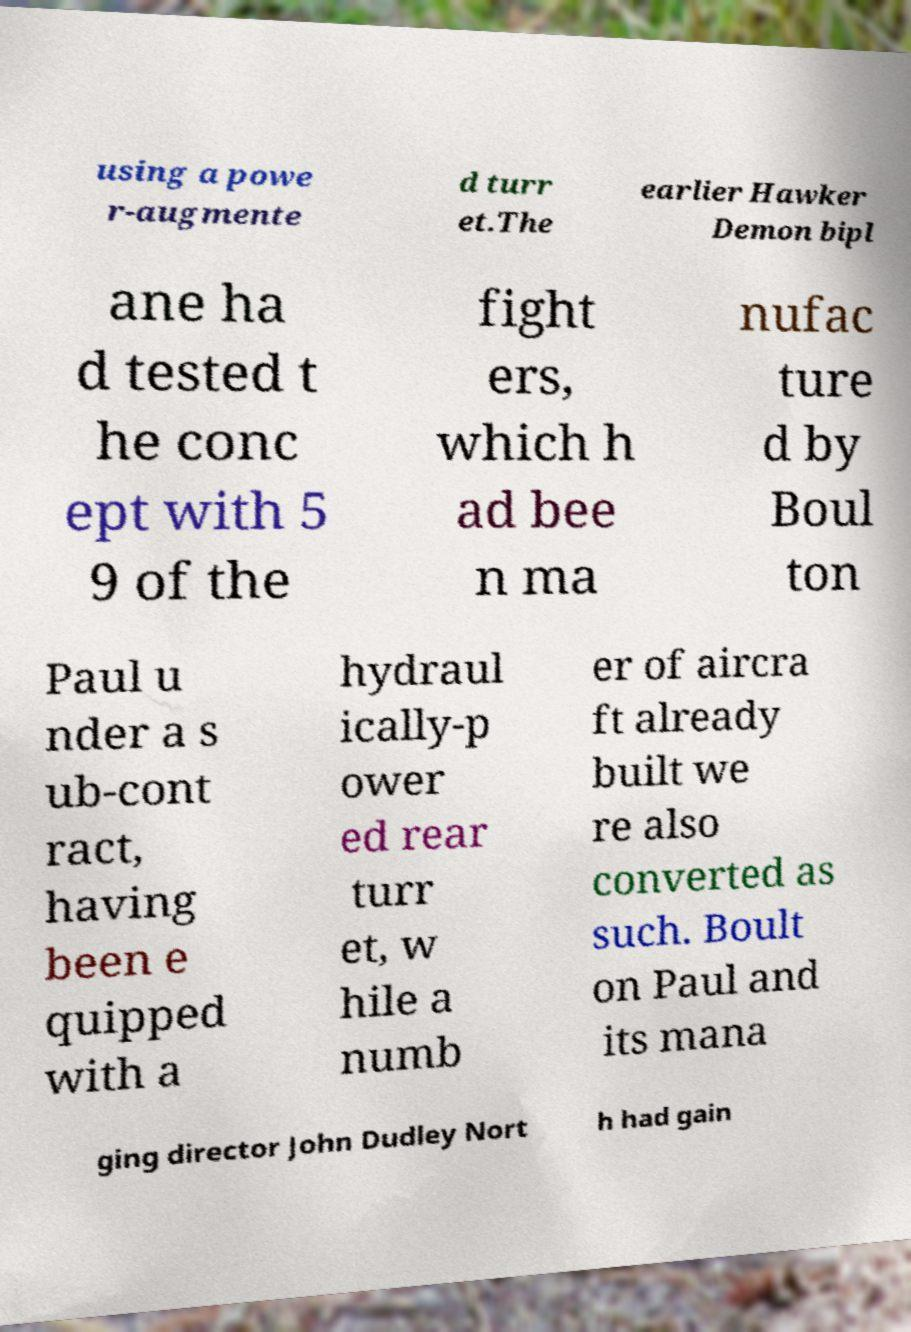Please identify and transcribe the text found in this image. using a powe r-augmente d turr et.The earlier Hawker Demon bipl ane ha d tested t he conc ept with 5 9 of the fight ers, which h ad bee n ma nufac ture d by Boul ton Paul u nder a s ub-cont ract, having been e quipped with a hydraul ically-p ower ed rear turr et, w hile a numb er of aircra ft already built we re also converted as such. Boult on Paul and its mana ging director John Dudley Nort h had gain 